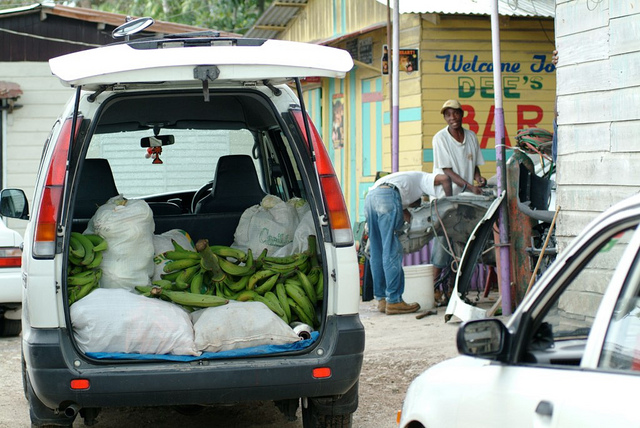Please transcribe the text information in this image. Welcome Jo DEE's BAR 